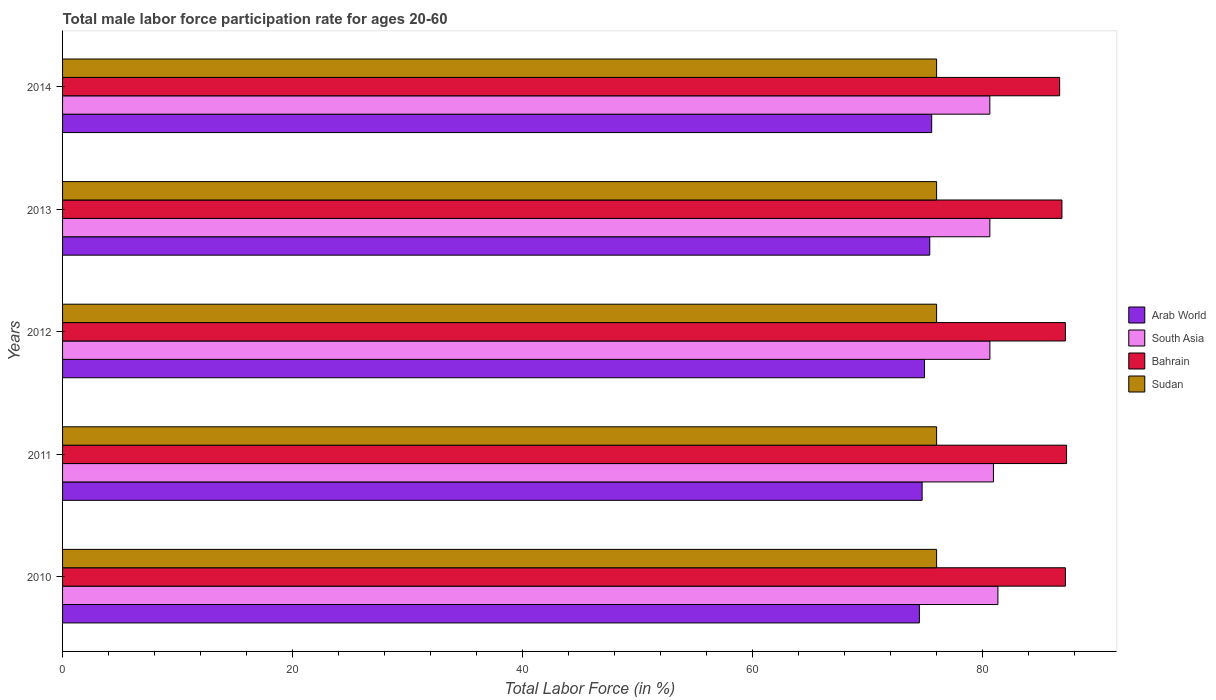How many different coloured bars are there?
Ensure brevity in your answer.  4. In how many cases, is the number of bars for a given year not equal to the number of legend labels?
Your response must be concise. 0. What is the male labor force participation rate in Arab World in 2013?
Make the answer very short. 75.41. Across all years, what is the maximum male labor force participation rate in Sudan?
Offer a terse response. 76. Across all years, what is the minimum male labor force participation rate in South Asia?
Offer a very short reply. 80.63. In which year was the male labor force participation rate in South Asia maximum?
Give a very brief answer. 2010. What is the total male labor force participation rate in Sudan in the graph?
Your response must be concise. 380. What is the difference between the male labor force participation rate in Arab World in 2010 and the male labor force participation rate in Sudan in 2011?
Provide a succinct answer. -1.5. What is the average male labor force participation rate in Bahrain per year?
Your response must be concise. 87.06. In the year 2013, what is the difference between the male labor force participation rate in Bahrain and male labor force participation rate in South Asia?
Your answer should be compact. 6.27. Is the male labor force participation rate in Bahrain in 2011 less than that in 2013?
Provide a short and direct response. No. What is the difference between the highest and the second highest male labor force participation rate in South Asia?
Your answer should be very brief. 0.39. What is the difference between the highest and the lowest male labor force participation rate in South Asia?
Your answer should be compact. 0.7. What does the 2nd bar from the top in 2014 represents?
Ensure brevity in your answer.  Bahrain. What does the 2nd bar from the bottom in 2011 represents?
Offer a terse response. South Asia. How many bars are there?
Provide a short and direct response. 20. Are all the bars in the graph horizontal?
Your answer should be compact. Yes. How many years are there in the graph?
Offer a very short reply. 5. Are the values on the major ticks of X-axis written in scientific E-notation?
Offer a very short reply. No. Does the graph contain grids?
Make the answer very short. No. How are the legend labels stacked?
Provide a succinct answer. Vertical. What is the title of the graph?
Provide a short and direct response. Total male labor force participation rate for ages 20-60. Does "Senegal" appear as one of the legend labels in the graph?
Give a very brief answer. No. What is the label or title of the X-axis?
Ensure brevity in your answer.  Total Labor Force (in %). What is the label or title of the Y-axis?
Provide a short and direct response. Years. What is the Total Labor Force (in %) in Arab World in 2010?
Your response must be concise. 74.5. What is the Total Labor Force (in %) of South Asia in 2010?
Give a very brief answer. 81.33. What is the Total Labor Force (in %) of Bahrain in 2010?
Provide a short and direct response. 87.2. What is the Total Labor Force (in %) of Arab World in 2011?
Ensure brevity in your answer.  74.74. What is the Total Labor Force (in %) of South Asia in 2011?
Your response must be concise. 80.94. What is the Total Labor Force (in %) in Bahrain in 2011?
Your response must be concise. 87.3. What is the Total Labor Force (in %) of Arab World in 2012?
Make the answer very short. 74.95. What is the Total Labor Force (in %) in South Asia in 2012?
Keep it short and to the point. 80.64. What is the Total Labor Force (in %) in Bahrain in 2012?
Provide a short and direct response. 87.2. What is the Total Labor Force (in %) in Sudan in 2012?
Make the answer very short. 76. What is the Total Labor Force (in %) in Arab World in 2013?
Your response must be concise. 75.41. What is the Total Labor Force (in %) in South Asia in 2013?
Provide a short and direct response. 80.63. What is the Total Labor Force (in %) of Bahrain in 2013?
Your answer should be very brief. 86.9. What is the Total Labor Force (in %) of Sudan in 2013?
Give a very brief answer. 76. What is the Total Labor Force (in %) of Arab World in 2014?
Your answer should be compact. 75.57. What is the Total Labor Force (in %) of South Asia in 2014?
Your response must be concise. 80.63. What is the Total Labor Force (in %) in Bahrain in 2014?
Offer a very short reply. 86.7. Across all years, what is the maximum Total Labor Force (in %) of Arab World?
Ensure brevity in your answer.  75.57. Across all years, what is the maximum Total Labor Force (in %) of South Asia?
Make the answer very short. 81.33. Across all years, what is the maximum Total Labor Force (in %) of Bahrain?
Offer a very short reply. 87.3. Across all years, what is the maximum Total Labor Force (in %) of Sudan?
Give a very brief answer. 76. Across all years, what is the minimum Total Labor Force (in %) in Arab World?
Keep it short and to the point. 74.5. Across all years, what is the minimum Total Labor Force (in %) of South Asia?
Make the answer very short. 80.63. Across all years, what is the minimum Total Labor Force (in %) in Bahrain?
Give a very brief answer. 86.7. What is the total Total Labor Force (in %) in Arab World in the graph?
Your answer should be very brief. 375.17. What is the total Total Labor Force (in %) in South Asia in the graph?
Offer a terse response. 404.17. What is the total Total Labor Force (in %) in Bahrain in the graph?
Give a very brief answer. 435.3. What is the total Total Labor Force (in %) of Sudan in the graph?
Make the answer very short. 380. What is the difference between the Total Labor Force (in %) of Arab World in 2010 and that in 2011?
Your answer should be very brief. -0.24. What is the difference between the Total Labor Force (in %) in South Asia in 2010 and that in 2011?
Offer a very short reply. 0.39. What is the difference between the Total Labor Force (in %) in Arab World in 2010 and that in 2012?
Provide a succinct answer. -0.45. What is the difference between the Total Labor Force (in %) in South Asia in 2010 and that in 2012?
Ensure brevity in your answer.  0.7. What is the difference between the Total Labor Force (in %) of Bahrain in 2010 and that in 2012?
Provide a succinct answer. 0. What is the difference between the Total Labor Force (in %) in Arab World in 2010 and that in 2013?
Your answer should be compact. -0.9. What is the difference between the Total Labor Force (in %) of South Asia in 2010 and that in 2013?
Make the answer very short. 0.7. What is the difference between the Total Labor Force (in %) in Sudan in 2010 and that in 2013?
Provide a succinct answer. 0. What is the difference between the Total Labor Force (in %) of Arab World in 2010 and that in 2014?
Provide a short and direct response. -1.07. What is the difference between the Total Labor Force (in %) of South Asia in 2010 and that in 2014?
Ensure brevity in your answer.  0.7. What is the difference between the Total Labor Force (in %) in Bahrain in 2010 and that in 2014?
Ensure brevity in your answer.  0.5. What is the difference between the Total Labor Force (in %) of Arab World in 2011 and that in 2012?
Keep it short and to the point. -0.21. What is the difference between the Total Labor Force (in %) in South Asia in 2011 and that in 2012?
Provide a succinct answer. 0.31. What is the difference between the Total Labor Force (in %) in Arab World in 2011 and that in 2013?
Your response must be concise. -0.67. What is the difference between the Total Labor Force (in %) in South Asia in 2011 and that in 2013?
Your response must be concise. 0.31. What is the difference between the Total Labor Force (in %) of Bahrain in 2011 and that in 2013?
Your response must be concise. 0.4. What is the difference between the Total Labor Force (in %) of Arab World in 2011 and that in 2014?
Offer a terse response. -0.83. What is the difference between the Total Labor Force (in %) in South Asia in 2011 and that in 2014?
Your response must be concise. 0.31. What is the difference between the Total Labor Force (in %) of Sudan in 2011 and that in 2014?
Offer a terse response. 0. What is the difference between the Total Labor Force (in %) of Arab World in 2012 and that in 2013?
Offer a terse response. -0.46. What is the difference between the Total Labor Force (in %) in South Asia in 2012 and that in 2013?
Keep it short and to the point. 0. What is the difference between the Total Labor Force (in %) of Sudan in 2012 and that in 2013?
Make the answer very short. 0. What is the difference between the Total Labor Force (in %) in Arab World in 2012 and that in 2014?
Give a very brief answer. -0.62. What is the difference between the Total Labor Force (in %) of South Asia in 2012 and that in 2014?
Offer a very short reply. 0.01. What is the difference between the Total Labor Force (in %) of Bahrain in 2012 and that in 2014?
Make the answer very short. 0.5. What is the difference between the Total Labor Force (in %) in Arab World in 2013 and that in 2014?
Keep it short and to the point. -0.16. What is the difference between the Total Labor Force (in %) in South Asia in 2013 and that in 2014?
Provide a succinct answer. 0. What is the difference between the Total Labor Force (in %) in Bahrain in 2013 and that in 2014?
Give a very brief answer. 0.2. What is the difference between the Total Labor Force (in %) of Sudan in 2013 and that in 2014?
Offer a very short reply. 0. What is the difference between the Total Labor Force (in %) in Arab World in 2010 and the Total Labor Force (in %) in South Asia in 2011?
Your answer should be very brief. -6.44. What is the difference between the Total Labor Force (in %) in Arab World in 2010 and the Total Labor Force (in %) in Bahrain in 2011?
Offer a very short reply. -12.8. What is the difference between the Total Labor Force (in %) of Arab World in 2010 and the Total Labor Force (in %) of Sudan in 2011?
Your answer should be compact. -1.5. What is the difference between the Total Labor Force (in %) in South Asia in 2010 and the Total Labor Force (in %) in Bahrain in 2011?
Ensure brevity in your answer.  -5.97. What is the difference between the Total Labor Force (in %) of South Asia in 2010 and the Total Labor Force (in %) of Sudan in 2011?
Keep it short and to the point. 5.33. What is the difference between the Total Labor Force (in %) of Arab World in 2010 and the Total Labor Force (in %) of South Asia in 2012?
Your answer should be compact. -6.13. What is the difference between the Total Labor Force (in %) of Arab World in 2010 and the Total Labor Force (in %) of Bahrain in 2012?
Give a very brief answer. -12.7. What is the difference between the Total Labor Force (in %) in Arab World in 2010 and the Total Labor Force (in %) in Sudan in 2012?
Offer a terse response. -1.5. What is the difference between the Total Labor Force (in %) in South Asia in 2010 and the Total Labor Force (in %) in Bahrain in 2012?
Provide a short and direct response. -5.87. What is the difference between the Total Labor Force (in %) of South Asia in 2010 and the Total Labor Force (in %) of Sudan in 2012?
Offer a terse response. 5.33. What is the difference between the Total Labor Force (in %) in Bahrain in 2010 and the Total Labor Force (in %) in Sudan in 2012?
Provide a short and direct response. 11.2. What is the difference between the Total Labor Force (in %) in Arab World in 2010 and the Total Labor Force (in %) in South Asia in 2013?
Give a very brief answer. -6.13. What is the difference between the Total Labor Force (in %) of Arab World in 2010 and the Total Labor Force (in %) of Bahrain in 2013?
Offer a terse response. -12.4. What is the difference between the Total Labor Force (in %) of Arab World in 2010 and the Total Labor Force (in %) of Sudan in 2013?
Make the answer very short. -1.5. What is the difference between the Total Labor Force (in %) in South Asia in 2010 and the Total Labor Force (in %) in Bahrain in 2013?
Keep it short and to the point. -5.57. What is the difference between the Total Labor Force (in %) of South Asia in 2010 and the Total Labor Force (in %) of Sudan in 2013?
Your answer should be very brief. 5.33. What is the difference between the Total Labor Force (in %) in Arab World in 2010 and the Total Labor Force (in %) in South Asia in 2014?
Your response must be concise. -6.13. What is the difference between the Total Labor Force (in %) in Arab World in 2010 and the Total Labor Force (in %) in Bahrain in 2014?
Your answer should be very brief. -12.2. What is the difference between the Total Labor Force (in %) in Arab World in 2010 and the Total Labor Force (in %) in Sudan in 2014?
Your answer should be compact. -1.5. What is the difference between the Total Labor Force (in %) of South Asia in 2010 and the Total Labor Force (in %) of Bahrain in 2014?
Make the answer very short. -5.37. What is the difference between the Total Labor Force (in %) of South Asia in 2010 and the Total Labor Force (in %) of Sudan in 2014?
Make the answer very short. 5.33. What is the difference between the Total Labor Force (in %) in Arab World in 2011 and the Total Labor Force (in %) in South Asia in 2012?
Keep it short and to the point. -5.89. What is the difference between the Total Labor Force (in %) of Arab World in 2011 and the Total Labor Force (in %) of Bahrain in 2012?
Your response must be concise. -12.46. What is the difference between the Total Labor Force (in %) of Arab World in 2011 and the Total Labor Force (in %) of Sudan in 2012?
Ensure brevity in your answer.  -1.26. What is the difference between the Total Labor Force (in %) of South Asia in 2011 and the Total Labor Force (in %) of Bahrain in 2012?
Keep it short and to the point. -6.26. What is the difference between the Total Labor Force (in %) in South Asia in 2011 and the Total Labor Force (in %) in Sudan in 2012?
Your answer should be very brief. 4.94. What is the difference between the Total Labor Force (in %) in Arab World in 2011 and the Total Labor Force (in %) in South Asia in 2013?
Give a very brief answer. -5.89. What is the difference between the Total Labor Force (in %) of Arab World in 2011 and the Total Labor Force (in %) of Bahrain in 2013?
Ensure brevity in your answer.  -12.16. What is the difference between the Total Labor Force (in %) of Arab World in 2011 and the Total Labor Force (in %) of Sudan in 2013?
Give a very brief answer. -1.26. What is the difference between the Total Labor Force (in %) of South Asia in 2011 and the Total Labor Force (in %) of Bahrain in 2013?
Your response must be concise. -5.96. What is the difference between the Total Labor Force (in %) in South Asia in 2011 and the Total Labor Force (in %) in Sudan in 2013?
Offer a very short reply. 4.94. What is the difference between the Total Labor Force (in %) in Bahrain in 2011 and the Total Labor Force (in %) in Sudan in 2013?
Provide a short and direct response. 11.3. What is the difference between the Total Labor Force (in %) of Arab World in 2011 and the Total Labor Force (in %) of South Asia in 2014?
Make the answer very short. -5.89. What is the difference between the Total Labor Force (in %) of Arab World in 2011 and the Total Labor Force (in %) of Bahrain in 2014?
Offer a terse response. -11.96. What is the difference between the Total Labor Force (in %) of Arab World in 2011 and the Total Labor Force (in %) of Sudan in 2014?
Offer a terse response. -1.26. What is the difference between the Total Labor Force (in %) of South Asia in 2011 and the Total Labor Force (in %) of Bahrain in 2014?
Offer a terse response. -5.76. What is the difference between the Total Labor Force (in %) of South Asia in 2011 and the Total Labor Force (in %) of Sudan in 2014?
Offer a very short reply. 4.94. What is the difference between the Total Labor Force (in %) in Arab World in 2012 and the Total Labor Force (in %) in South Asia in 2013?
Keep it short and to the point. -5.68. What is the difference between the Total Labor Force (in %) of Arab World in 2012 and the Total Labor Force (in %) of Bahrain in 2013?
Keep it short and to the point. -11.95. What is the difference between the Total Labor Force (in %) of Arab World in 2012 and the Total Labor Force (in %) of Sudan in 2013?
Offer a terse response. -1.05. What is the difference between the Total Labor Force (in %) of South Asia in 2012 and the Total Labor Force (in %) of Bahrain in 2013?
Your response must be concise. -6.26. What is the difference between the Total Labor Force (in %) in South Asia in 2012 and the Total Labor Force (in %) in Sudan in 2013?
Ensure brevity in your answer.  4.63. What is the difference between the Total Labor Force (in %) in Bahrain in 2012 and the Total Labor Force (in %) in Sudan in 2013?
Keep it short and to the point. 11.2. What is the difference between the Total Labor Force (in %) in Arab World in 2012 and the Total Labor Force (in %) in South Asia in 2014?
Offer a terse response. -5.68. What is the difference between the Total Labor Force (in %) in Arab World in 2012 and the Total Labor Force (in %) in Bahrain in 2014?
Your answer should be very brief. -11.75. What is the difference between the Total Labor Force (in %) in Arab World in 2012 and the Total Labor Force (in %) in Sudan in 2014?
Provide a succinct answer. -1.05. What is the difference between the Total Labor Force (in %) of South Asia in 2012 and the Total Labor Force (in %) of Bahrain in 2014?
Make the answer very short. -6.07. What is the difference between the Total Labor Force (in %) of South Asia in 2012 and the Total Labor Force (in %) of Sudan in 2014?
Offer a terse response. 4.63. What is the difference between the Total Labor Force (in %) in Bahrain in 2012 and the Total Labor Force (in %) in Sudan in 2014?
Give a very brief answer. 11.2. What is the difference between the Total Labor Force (in %) of Arab World in 2013 and the Total Labor Force (in %) of South Asia in 2014?
Your answer should be compact. -5.22. What is the difference between the Total Labor Force (in %) of Arab World in 2013 and the Total Labor Force (in %) of Bahrain in 2014?
Offer a terse response. -11.29. What is the difference between the Total Labor Force (in %) in Arab World in 2013 and the Total Labor Force (in %) in Sudan in 2014?
Offer a terse response. -0.59. What is the difference between the Total Labor Force (in %) of South Asia in 2013 and the Total Labor Force (in %) of Bahrain in 2014?
Ensure brevity in your answer.  -6.07. What is the difference between the Total Labor Force (in %) of South Asia in 2013 and the Total Labor Force (in %) of Sudan in 2014?
Your answer should be very brief. 4.63. What is the difference between the Total Labor Force (in %) in Bahrain in 2013 and the Total Labor Force (in %) in Sudan in 2014?
Your response must be concise. 10.9. What is the average Total Labor Force (in %) in Arab World per year?
Your response must be concise. 75.03. What is the average Total Labor Force (in %) of South Asia per year?
Provide a succinct answer. 80.83. What is the average Total Labor Force (in %) of Bahrain per year?
Make the answer very short. 87.06. What is the average Total Labor Force (in %) in Sudan per year?
Keep it short and to the point. 76. In the year 2010, what is the difference between the Total Labor Force (in %) in Arab World and Total Labor Force (in %) in South Asia?
Keep it short and to the point. -6.83. In the year 2010, what is the difference between the Total Labor Force (in %) of Arab World and Total Labor Force (in %) of Bahrain?
Keep it short and to the point. -12.7. In the year 2010, what is the difference between the Total Labor Force (in %) of Arab World and Total Labor Force (in %) of Sudan?
Provide a short and direct response. -1.5. In the year 2010, what is the difference between the Total Labor Force (in %) of South Asia and Total Labor Force (in %) of Bahrain?
Provide a succinct answer. -5.87. In the year 2010, what is the difference between the Total Labor Force (in %) in South Asia and Total Labor Force (in %) in Sudan?
Ensure brevity in your answer.  5.33. In the year 2011, what is the difference between the Total Labor Force (in %) in Arab World and Total Labor Force (in %) in South Asia?
Offer a terse response. -6.2. In the year 2011, what is the difference between the Total Labor Force (in %) of Arab World and Total Labor Force (in %) of Bahrain?
Your answer should be compact. -12.56. In the year 2011, what is the difference between the Total Labor Force (in %) in Arab World and Total Labor Force (in %) in Sudan?
Your answer should be very brief. -1.26. In the year 2011, what is the difference between the Total Labor Force (in %) of South Asia and Total Labor Force (in %) of Bahrain?
Your response must be concise. -6.36. In the year 2011, what is the difference between the Total Labor Force (in %) in South Asia and Total Labor Force (in %) in Sudan?
Your answer should be compact. 4.94. In the year 2012, what is the difference between the Total Labor Force (in %) in Arab World and Total Labor Force (in %) in South Asia?
Ensure brevity in your answer.  -5.68. In the year 2012, what is the difference between the Total Labor Force (in %) in Arab World and Total Labor Force (in %) in Bahrain?
Ensure brevity in your answer.  -12.25. In the year 2012, what is the difference between the Total Labor Force (in %) in Arab World and Total Labor Force (in %) in Sudan?
Your answer should be compact. -1.05. In the year 2012, what is the difference between the Total Labor Force (in %) of South Asia and Total Labor Force (in %) of Bahrain?
Offer a very short reply. -6.57. In the year 2012, what is the difference between the Total Labor Force (in %) of South Asia and Total Labor Force (in %) of Sudan?
Offer a terse response. 4.63. In the year 2013, what is the difference between the Total Labor Force (in %) in Arab World and Total Labor Force (in %) in South Asia?
Provide a succinct answer. -5.22. In the year 2013, what is the difference between the Total Labor Force (in %) of Arab World and Total Labor Force (in %) of Bahrain?
Make the answer very short. -11.49. In the year 2013, what is the difference between the Total Labor Force (in %) in Arab World and Total Labor Force (in %) in Sudan?
Provide a short and direct response. -0.59. In the year 2013, what is the difference between the Total Labor Force (in %) of South Asia and Total Labor Force (in %) of Bahrain?
Your answer should be compact. -6.27. In the year 2013, what is the difference between the Total Labor Force (in %) in South Asia and Total Labor Force (in %) in Sudan?
Provide a short and direct response. 4.63. In the year 2013, what is the difference between the Total Labor Force (in %) of Bahrain and Total Labor Force (in %) of Sudan?
Provide a succinct answer. 10.9. In the year 2014, what is the difference between the Total Labor Force (in %) in Arab World and Total Labor Force (in %) in South Asia?
Your answer should be very brief. -5.06. In the year 2014, what is the difference between the Total Labor Force (in %) of Arab World and Total Labor Force (in %) of Bahrain?
Ensure brevity in your answer.  -11.13. In the year 2014, what is the difference between the Total Labor Force (in %) of Arab World and Total Labor Force (in %) of Sudan?
Provide a short and direct response. -0.43. In the year 2014, what is the difference between the Total Labor Force (in %) of South Asia and Total Labor Force (in %) of Bahrain?
Keep it short and to the point. -6.07. In the year 2014, what is the difference between the Total Labor Force (in %) in South Asia and Total Labor Force (in %) in Sudan?
Give a very brief answer. 4.63. What is the ratio of the Total Labor Force (in %) in Arab World in 2010 to that in 2011?
Provide a succinct answer. 1. What is the ratio of the Total Labor Force (in %) of South Asia in 2010 to that in 2011?
Your answer should be very brief. 1. What is the ratio of the Total Labor Force (in %) of South Asia in 2010 to that in 2012?
Keep it short and to the point. 1.01. What is the ratio of the Total Labor Force (in %) of Bahrain in 2010 to that in 2012?
Offer a terse response. 1. What is the ratio of the Total Labor Force (in %) of South Asia in 2010 to that in 2013?
Your response must be concise. 1.01. What is the ratio of the Total Labor Force (in %) of Sudan in 2010 to that in 2013?
Your answer should be very brief. 1. What is the ratio of the Total Labor Force (in %) in Arab World in 2010 to that in 2014?
Give a very brief answer. 0.99. What is the ratio of the Total Labor Force (in %) of South Asia in 2010 to that in 2014?
Your answer should be very brief. 1.01. What is the ratio of the Total Labor Force (in %) in Sudan in 2010 to that in 2014?
Your response must be concise. 1. What is the ratio of the Total Labor Force (in %) in Bahrain in 2011 to that in 2012?
Offer a very short reply. 1. What is the ratio of the Total Labor Force (in %) of South Asia in 2011 to that in 2014?
Ensure brevity in your answer.  1. What is the ratio of the Total Labor Force (in %) of Sudan in 2011 to that in 2014?
Your answer should be very brief. 1. What is the ratio of the Total Labor Force (in %) of South Asia in 2012 to that in 2013?
Provide a succinct answer. 1. What is the ratio of the Total Labor Force (in %) in Bahrain in 2012 to that in 2013?
Your answer should be very brief. 1. What is the ratio of the Total Labor Force (in %) of Sudan in 2012 to that in 2013?
Offer a terse response. 1. What is the ratio of the Total Labor Force (in %) of Arab World in 2012 to that in 2014?
Offer a terse response. 0.99. What is the ratio of the Total Labor Force (in %) of Arab World in 2013 to that in 2014?
Your response must be concise. 1. What is the ratio of the Total Labor Force (in %) in Sudan in 2013 to that in 2014?
Offer a very short reply. 1. What is the difference between the highest and the second highest Total Labor Force (in %) in Arab World?
Make the answer very short. 0.16. What is the difference between the highest and the second highest Total Labor Force (in %) in South Asia?
Your answer should be compact. 0.39. What is the difference between the highest and the second highest Total Labor Force (in %) of Sudan?
Give a very brief answer. 0. What is the difference between the highest and the lowest Total Labor Force (in %) in Arab World?
Keep it short and to the point. 1.07. What is the difference between the highest and the lowest Total Labor Force (in %) of South Asia?
Give a very brief answer. 0.7. 